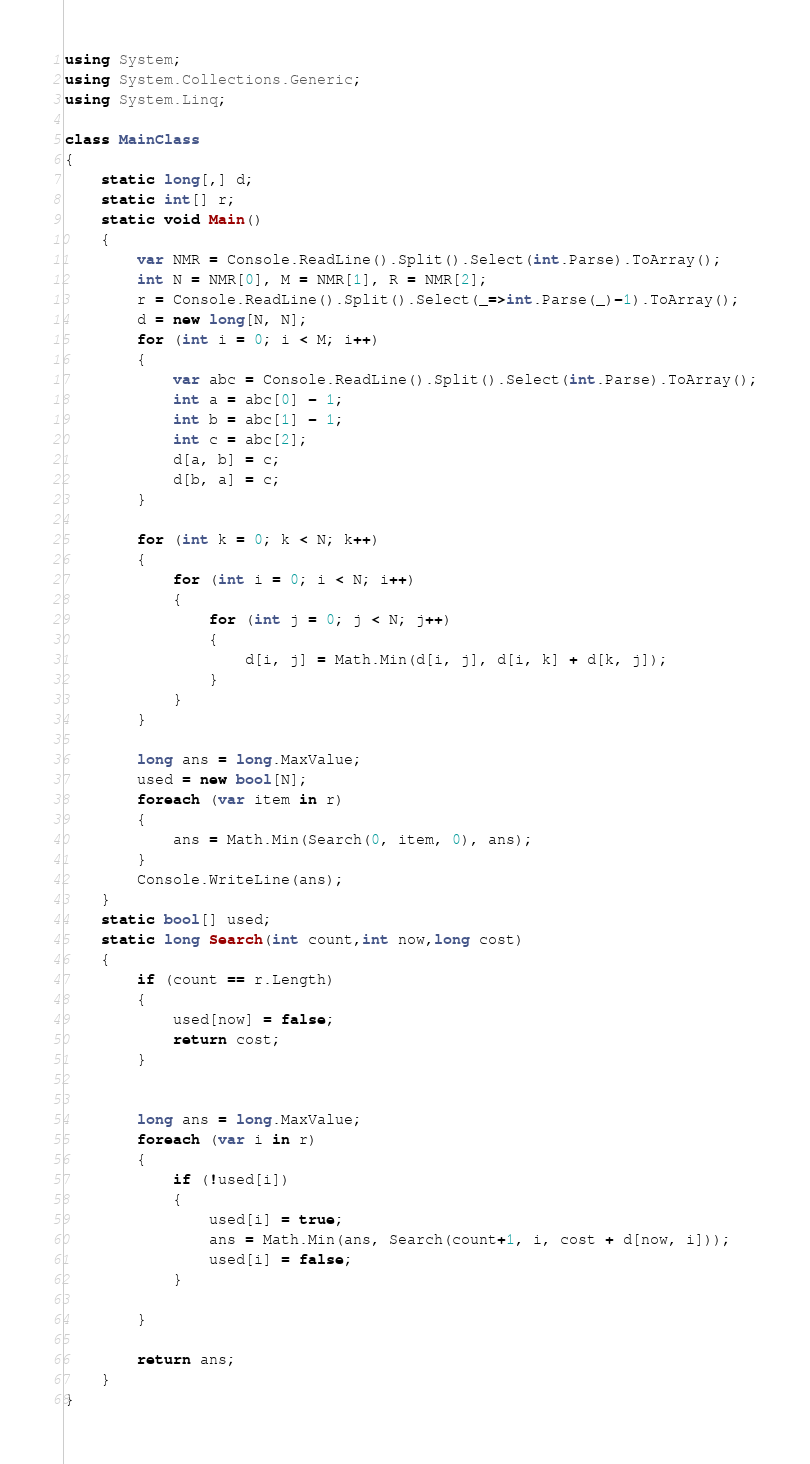Convert code to text. <code><loc_0><loc_0><loc_500><loc_500><_C#_>using System;
using System.Collections.Generic;
using System.Linq;

class MainClass
{
    static long[,] d;
    static int[] r;
    static void Main()
    {
        var NMR = Console.ReadLine().Split().Select(int.Parse).ToArray();
        int N = NMR[0], M = NMR[1], R = NMR[2];
        r = Console.ReadLine().Split().Select(_=>int.Parse(_)-1).ToArray();
        d = new long[N, N];
        for (int i = 0; i < M; i++)
        {
            var abc = Console.ReadLine().Split().Select(int.Parse).ToArray();
            int a = abc[0] - 1;
            int b = abc[1] - 1;
            int c = abc[2];
            d[a, b] = c;
            d[b, a] = c;
        }

        for (int k = 0; k < N; k++)
        {
            for (int i = 0; i < N; i++)
            {
                for (int j = 0; j < N; j++)
                {
                    d[i, j] = Math.Min(d[i, j], d[i, k] + d[k, j]);
                }
            }
        }

        long ans = long.MaxValue;
        used = new bool[N];
        foreach (var item in r)
        {
            ans = Math.Min(Search(0, item, 0), ans);
        }
        Console.WriteLine(ans);
    }
    static bool[] used;
    static long Search(int count,int now,long cost)
    {
        if (count == r.Length)
        {
            used[now] = false;
            return cost;
        }
        

        long ans = long.MaxValue;
        foreach (var i in r)
        {
            if (!used[i])
            {
                used[i] = true;
                ans = Math.Min(ans, Search(count+1, i, cost + d[now, i]));
                used[i] = false;
            }
                
        }

        return ans;
    }
}
</code> 